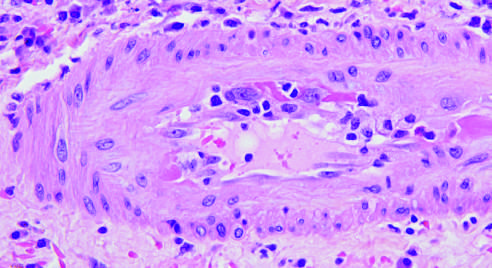what is an arteriole shown with?
Answer the question using a single word or phrase. Inflammatory cells 